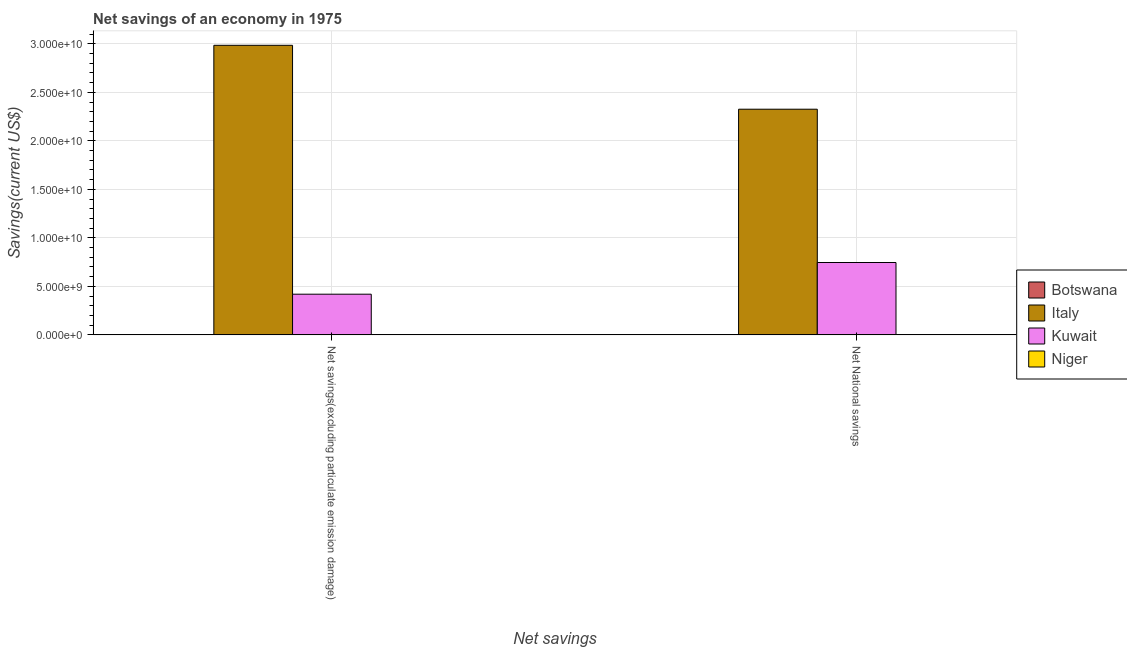How many different coloured bars are there?
Your answer should be very brief. 4. Are the number of bars on each tick of the X-axis equal?
Provide a succinct answer. Yes. How many bars are there on the 2nd tick from the left?
Your response must be concise. 4. What is the label of the 1st group of bars from the left?
Provide a short and direct response. Net savings(excluding particulate emission damage). What is the net national savings in Italy?
Your answer should be very brief. 2.33e+1. Across all countries, what is the maximum net savings(excluding particulate emission damage)?
Offer a terse response. 2.98e+1. Across all countries, what is the minimum net national savings?
Keep it short and to the point. 2.15e+07. In which country was the net national savings maximum?
Ensure brevity in your answer.  Italy. In which country was the net national savings minimum?
Your answer should be compact. Botswana. What is the total net savings(excluding particulate emission damage) in the graph?
Offer a terse response. 3.41e+1. What is the difference between the net national savings in Niger and that in Botswana?
Make the answer very short. 1.65e+07. What is the difference between the net national savings in Kuwait and the net savings(excluding particulate emission damage) in Italy?
Make the answer very short. -2.24e+1. What is the average net savings(excluding particulate emission damage) per country?
Offer a terse response. 8.53e+09. What is the difference between the net savings(excluding particulate emission damage) and net national savings in Italy?
Give a very brief answer. 6.59e+09. In how many countries, is the net savings(excluding particulate emission damage) greater than 13000000000 US$?
Ensure brevity in your answer.  1. What is the ratio of the net savings(excluding particulate emission damage) in Italy to that in Botswana?
Provide a succinct answer. 1128.76. In how many countries, is the net savings(excluding particulate emission damage) greater than the average net savings(excluding particulate emission damage) taken over all countries?
Offer a very short reply. 1. What does the 4th bar from the left in Net National savings represents?
Your response must be concise. Niger. What does the 3rd bar from the right in Net savings(excluding particulate emission damage) represents?
Ensure brevity in your answer.  Italy. Are all the bars in the graph horizontal?
Offer a very short reply. No. How many countries are there in the graph?
Ensure brevity in your answer.  4. What is the difference between two consecutive major ticks on the Y-axis?
Offer a terse response. 5.00e+09. Are the values on the major ticks of Y-axis written in scientific E-notation?
Provide a succinct answer. Yes. How many legend labels are there?
Your answer should be compact. 4. What is the title of the graph?
Provide a succinct answer. Net savings of an economy in 1975. What is the label or title of the X-axis?
Your answer should be very brief. Net savings. What is the label or title of the Y-axis?
Offer a terse response. Savings(current US$). What is the Savings(current US$) of Botswana in Net savings(excluding particulate emission damage)?
Give a very brief answer. 2.64e+07. What is the Savings(current US$) of Italy in Net savings(excluding particulate emission damage)?
Your answer should be compact. 2.98e+1. What is the Savings(current US$) of Kuwait in Net savings(excluding particulate emission damage)?
Your response must be concise. 4.19e+09. What is the Savings(current US$) of Niger in Net savings(excluding particulate emission damage)?
Provide a short and direct response. 3.84e+07. What is the Savings(current US$) of Botswana in Net National savings?
Provide a short and direct response. 2.15e+07. What is the Savings(current US$) of Italy in Net National savings?
Your answer should be compact. 2.33e+1. What is the Savings(current US$) of Kuwait in Net National savings?
Ensure brevity in your answer.  7.46e+09. What is the Savings(current US$) of Niger in Net National savings?
Your response must be concise. 3.80e+07. Across all Net savings, what is the maximum Savings(current US$) in Botswana?
Your answer should be compact. 2.64e+07. Across all Net savings, what is the maximum Savings(current US$) of Italy?
Your response must be concise. 2.98e+1. Across all Net savings, what is the maximum Savings(current US$) in Kuwait?
Your answer should be compact. 7.46e+09. Across all Net savings, what is the maximum Savings(current US$) in Niger?
Provide a short and direct response. 3.84e+07. Across all Net savings, what is the minimum Savings(current US$) of Botswana?
Keep it short and to the point. 2.15e+07. Across all Net savings, what is the minimum Savings(current US$) of Italy?
Offer a terse response. 2.33e+1. Across all Net savings, what is the minimum Savings(current US$) in Kuwait?
Keep it short and to the point. 4.19e+09. Across all Net savings, what is the minimum Savings(current US$) in Niger?
Make the answer very short. 3.80e+07. What is the total Savings(current US$) of Botswana in the graph?
Provide a succinct answer. 4.79e+07. What is the total Savings(current US$) of Italy in the graph?
Offer a very short reply. 5.31e+1. What is the total Savings(current US$) of Kuwait in the graph?
Give a very brief answer. 1.17e+1. What is the total Savings(current US$) of Niger in the graph?
Ensure brevity in your answer.  7.64e+07. What is the difference between the Savings(current US$) in Botswana in Net savings(excluding particulate emission damage) and that in Net National savings?
Your answer should be very brief. 4.97e+06. What is the difference between the Savings(current US$) of Italy in Net savings(excluding particulate emission damage) and that in Net National savings?
Offer a very short reply. 6.59e+09. What is the difference between the Savings(current US$) in Kuwait in Net savings(excluding particulate emission damage) and that in Net National savings?
Your answer should be very brief. -3.27e+09. What is the difference between the Savings(current US$) in Niger in Net savings(excluding particulate emission damage) and that in Net National savings?
Make the answer very short. 3.95e+05. What is the difference between the Savings(current US$) of Botswana in Net savings(excluding particulate emission damage) and the Savings(current US$) of Italy in Net National savings?
Your response must be concise. -2.32e+1. What is the difference between the Savings(current US$) in Botswana in Net savings(excluding particulate emission damage) and the Savings(current US$) in Kuwait in Net National savings?
Make the answer very short. -7.43e+09. What is the difference between the Savings(current US$) in Botswana in Net savings(excluding particulate emission damage) and the Savings(current US$) in Niger in Net National savings?
Your answer should be very brief. -1.16e+07. What is the difference between the Savings(current US$) of Italy in Net savings(excluding particulate emission damage) and the Savings(current US$) of Kuwait in Net National savings?
Your answer should be very brief. 2.24e+1. What is the difference between the Savings(current US$) of Italy in Net savings(excluding particulate emission damage) and the Savings(current US$) of Niger in Net National savings?
Provide a succinct answer. 2.98e+1. What is the difference between the Savings(current US$) of Kuwait in Net savings(excluding particulate emission damage) and the Savings(current US$) of Niger in Net National savings?
Ensure brevity in your answer.  4.16e+09. What is the average Savings(current US$) of Botswana per Net savings?
Your answer should be compact. 2.40e+07. What is the average Savings(current US$) of Italy per Net savings?
Your answer should be very brief. 2.66e+1. What is the average Savings(current US$) in Kuwait per Net savings?
Provide a succinct answer. 5.83e+09. What is the average Savings(current US$) of Niger per Net savings?
Give a very brief answer. 3.82e+07. What is the difference between the Savings(current US$) in Botswana and Savings(current US$) in Italy in Net savings(excluding particulate emission damage)?
Provide a succinct answer. -2.98e+1. What is the difference between the Savings(current US$) in Botswana and Savings(current US$) in Kuwait in Net savings(excluding particulate emission damage)?
Your answer should be very brief. -4.17e+09. What is the difference between the Savings(current US$) of Botswana and Savings(current US$) of Niger in Net savings(excluding particulate emission damage)?
Your response must be concise. -1.20e+07. What is the difference between the Savings(current US$) of Italy and Savings(current US$) of Kuwait in Net savings(excluding particulate emission damage)?
Your response must be concise. 2.57e+1. What is the difference between the Savings(current US$) in Italy and Savings(current US$) in Niger in Net savings(excluding particulate emission damage)?
Make the answer very short. 2.98e+1. What is the difference between the Savings(current US$) in Kuwait and Savings(current US$) in Niger in Net savings(excluding particulate emission damage)?
Ensure brevity in your answer.  4.16e+09. What is the difference between the Savings(current US$) in Botswana and Savings(current US$) in Italy in Net National savings?
Give a very brief answer. -2.32e+1. What is the difference between the Savings(current US$) in Botswana and Savings(current US$) in Kuwait in Net National savings?
Give a very brief answer. -7.44e+09. What is the difference between the Savings(current US$) of Botswana and Savings(current US$) of Niger in Net National savings?
Provide a succinct answer. -1.65e+07. What is the difference between the Savings(current US$) in Italy and Savings(current US$) in Kuwait in Net National savings?
Ensure brevity in your answer.  1.58e+1. What is the difference between the Savings(current US$) of Italy and Savings(current US$) of Niger in Net National savings?
Give a very brief answer. 2.32e+1. What is the difference between the Savings(current US$) in Kuwait and Savings(current US$) in Niger in Net National savings?
Ensure brevity in your answer.  7.42e+09. What is the ratio of the Savings(current US$) of Botswana in Net savings(excluding particulate emission damage) to that in Net National savings?
Your answer should be very brief. 1.23. What is the ratio of the Savings(current US$) of Italy in Net savings(excluding particulate emission damage) to that in Net National savings?
Ensure brevity in your answer.  1.28. What is the ratio of the Savings(current US$) in Kuwait in Net savings(excluding particulate emission damage) to that in Net National savings?
Your answer should be compact. 0.56. What is the ratio of the Savings(current US$) in Niger in Net savings(excluding particulate emission damage) to that in Net National savings?
Keep it short and to the point. 1.01. What is the difference between the highest and the second highest Savings(current US$) of Botswana?
Your answer should be compact. 4.97e+06. What is the difference between the highest and the second highest Savings(current US$) of Italy?
Offer a very short reply. 6.59e+09. What is the difference between the highest and the second highest Savings(current US$) of Kuwait?
Offer a very short reply. 3.27e+09. What is the difference between the highest and the second highest Savings(current US$) in Niger?
Keep it short and to the point. 3.95e+05. What is the difference between the highest and the lowest Savings(current US$) in Botswana?
Provide a succinct answer. 4.97e+06. What is the difference between the highest and the lowest Savings(current US$) of Italy?
Provide a short and direct response. 6.59e+09. What is the difference between the highest and the lowest Savings(current US$) of Kuwait?
Offer a terse response. 3.27e+09. What is the difference between the highest and the lowest Savings(current US$) in Niger?
Give a very brief answer. 3.95e+05. 